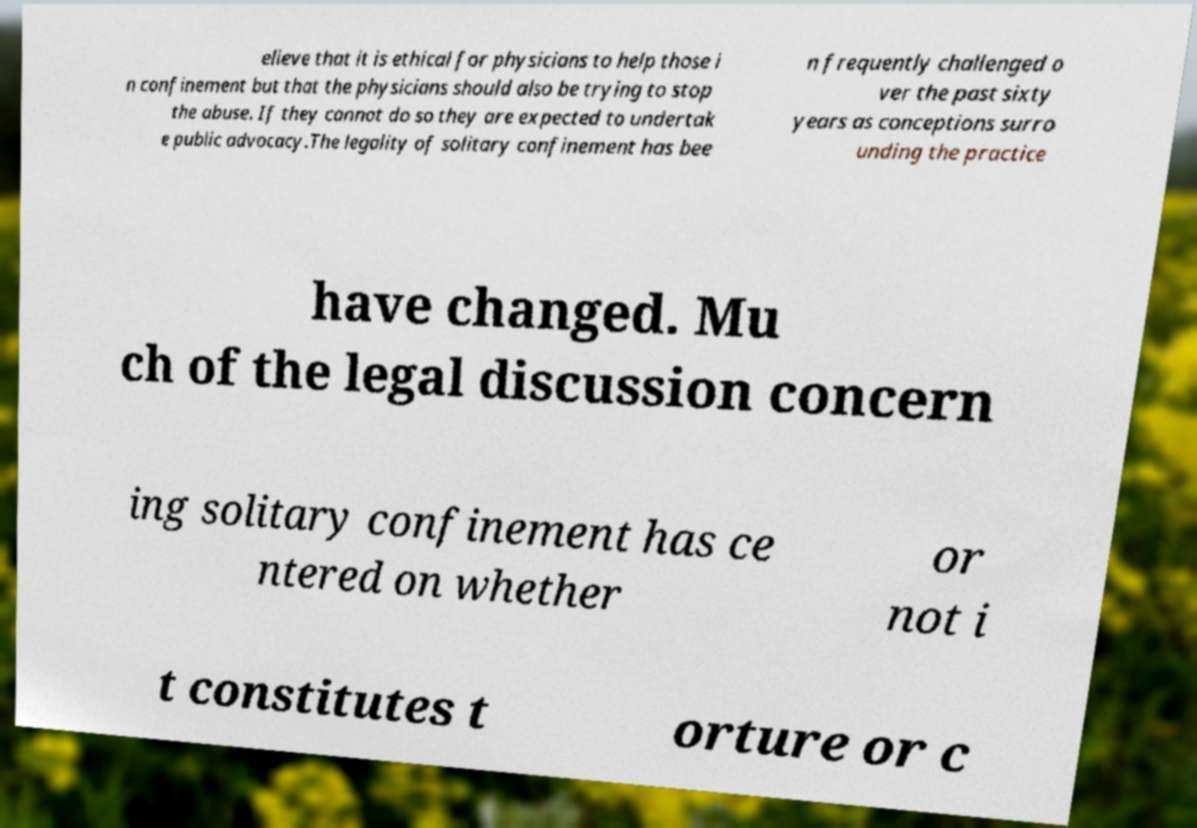Could you extract and type out the text from this image? elieve that it is ethical for physicians to help those i n confinement but that the physicians should also be trying to stop the abuse. If they cannot do so they are expected to undertak e public advocacy.The legality of solitary confinement has bee n frequently challenged o ver the past sixty years as conceptions surro unding the practice have changed. Mu ch of the legal discussion concern ing solitary confinement has ce ntered on whether or not i t constitutes t orture or c 